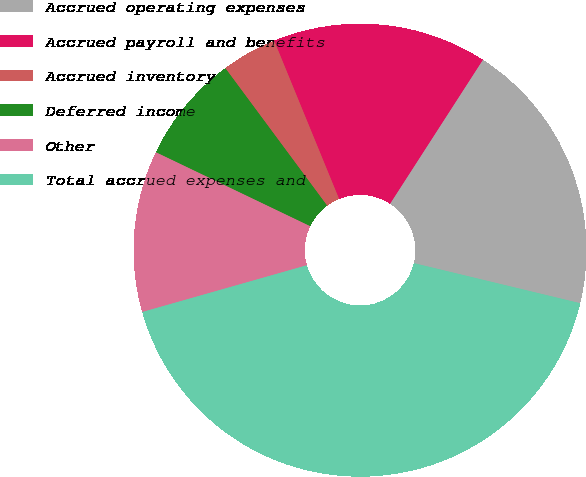<chart> <loc_0><loc_0><loc_500><loc_500><pie_chart><fcel>Accrued operating expenses<fcel>Accrued payroll and benefits<fcel>Accrued inventory<fcel>Deferred income<fcel>Other<fcel>Total accrued expenses and<nl><fcel>19.65%<fcel>15.31%<fcel>3.95%<fcel>7.74%<fcel>11.52%<fcel>41.83%<nl></chart> 